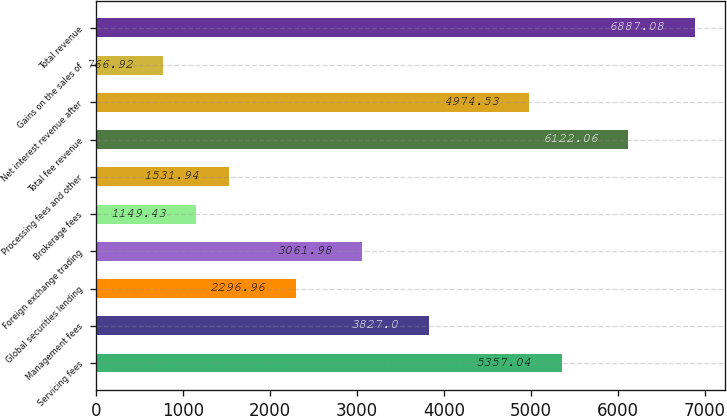<chart> <loc_0><loc_0><loc_500><loc_500><bar_chart><fcel>Servicing fees<fcel>Management fees<fcel>Global securities lending<fcel>Foreign exchange trading<fcel>Brokerage fees<fcel>Processing fees and other<fcel>Total fee revenue<fcel>Net interest revenue after<fcel>Gains on the sales of<fcel>Total revenue<nl><fcel>5357.04<fcel>3827<fcel>2296.96<fcel>3061.98<fcel>1149.43<fcel>1531.94<fcel>6122.06<fcel>4974.53<fcel>766.92<fcel>6887.08<nl></chart> 